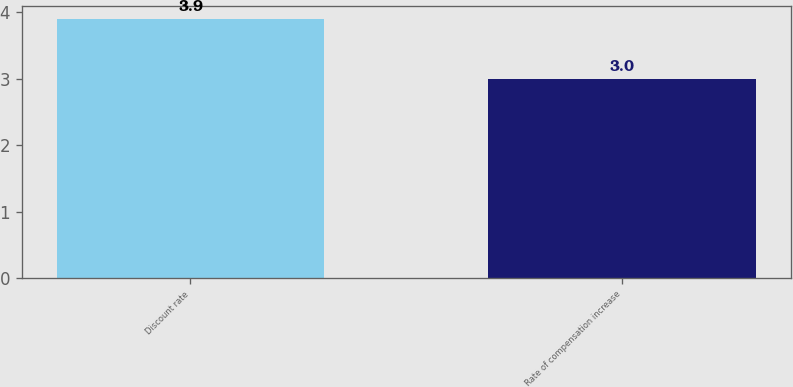<chart> <loc_0><loc_0><loc_500><loc_500><bar_chart><fcel>Discount rate<fcel>Rate of compensation increase<nl><fcel>3.9<fcel>3<nl></chart> 